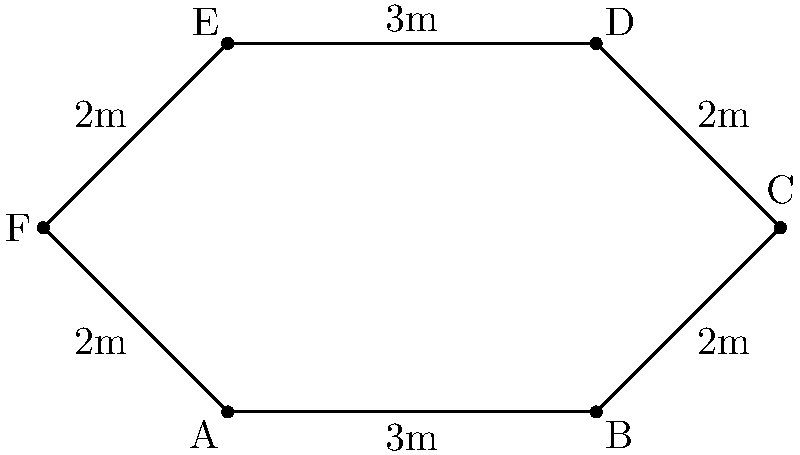You're designing a new hexagonal wrestling ring for your training facility. The ring has alternating side lengths of 3 meters and 2 meters, as shown in the diagram. What is the perimeter of this wrestling ring? To find the perimeter of the hexagonal wrestling ring, we need to add up the lengths of all sides. Let's break it down step-by-step:

1. Identify the side lengths:
   - There are two sides with length 3 meters
   - There are four sides with length 2 meters

2. Add up all the side lengths:
   $$ \text{Perimeter} = 3\text{m} + 2\text{m} + 2\text{m} + 3\text{m} + 2\text{m} + 2\text{m} $$

3. Simplify the addition:
   $$ \text{Perimeter} = (3\text{m} \times 2) + (2\text{m} \times 4) $$
   $$ \text{Perimeter} = 6\text{m} + 8\text{m} $$

4. Calculate the final result:
   $$ \text{Perimeter} = 14\text{m} $$

Therefore, the perimeter of the hexagonal wrestling ring is 14 meters.
Answer: 14 meters 